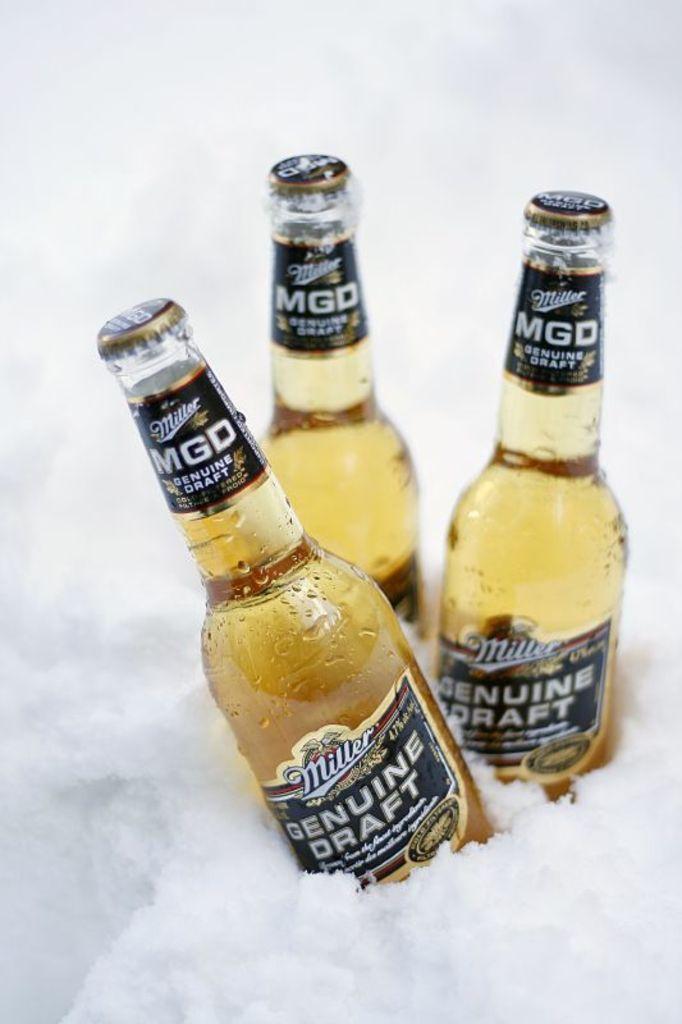Who is the manufacturer of this beer?
Make the answer very short. Miller. 